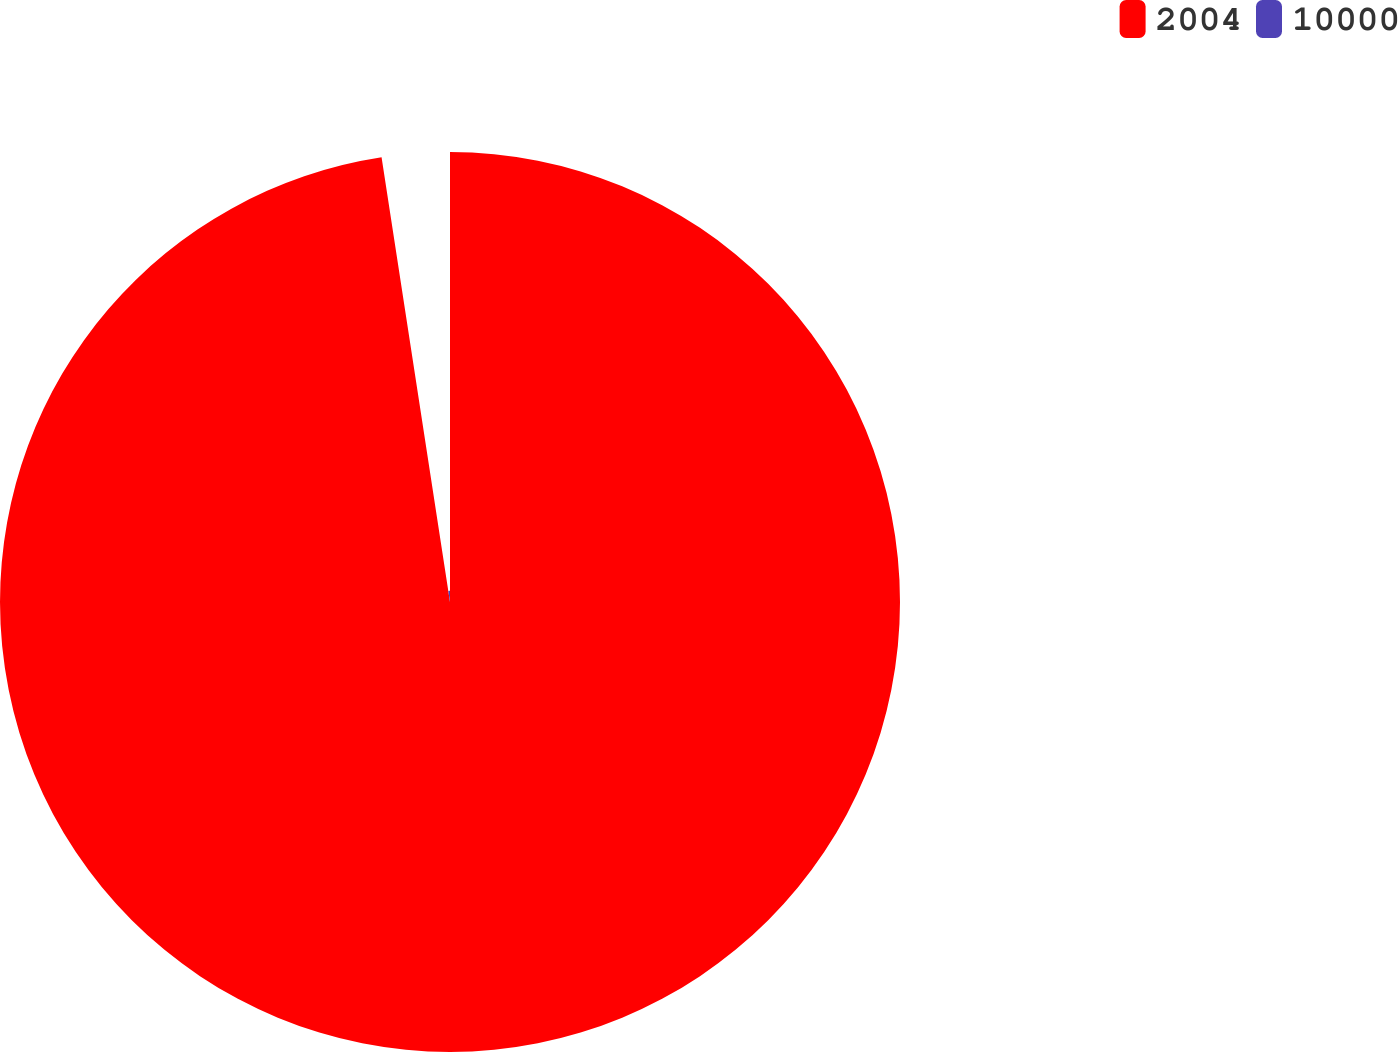Convert chart to OTSL. <chart><loc_0><loc_0><loc_500><loc_500><pie_chart><fcel>2004<fcel>10000<nl><fcel>97.57%<fcel>2.43%<nl></chart> 